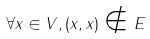<formula> <loc_0><loc_0><loc_500><loc_500>\forall x \in V , ( x , x ) \notin E</formula> 